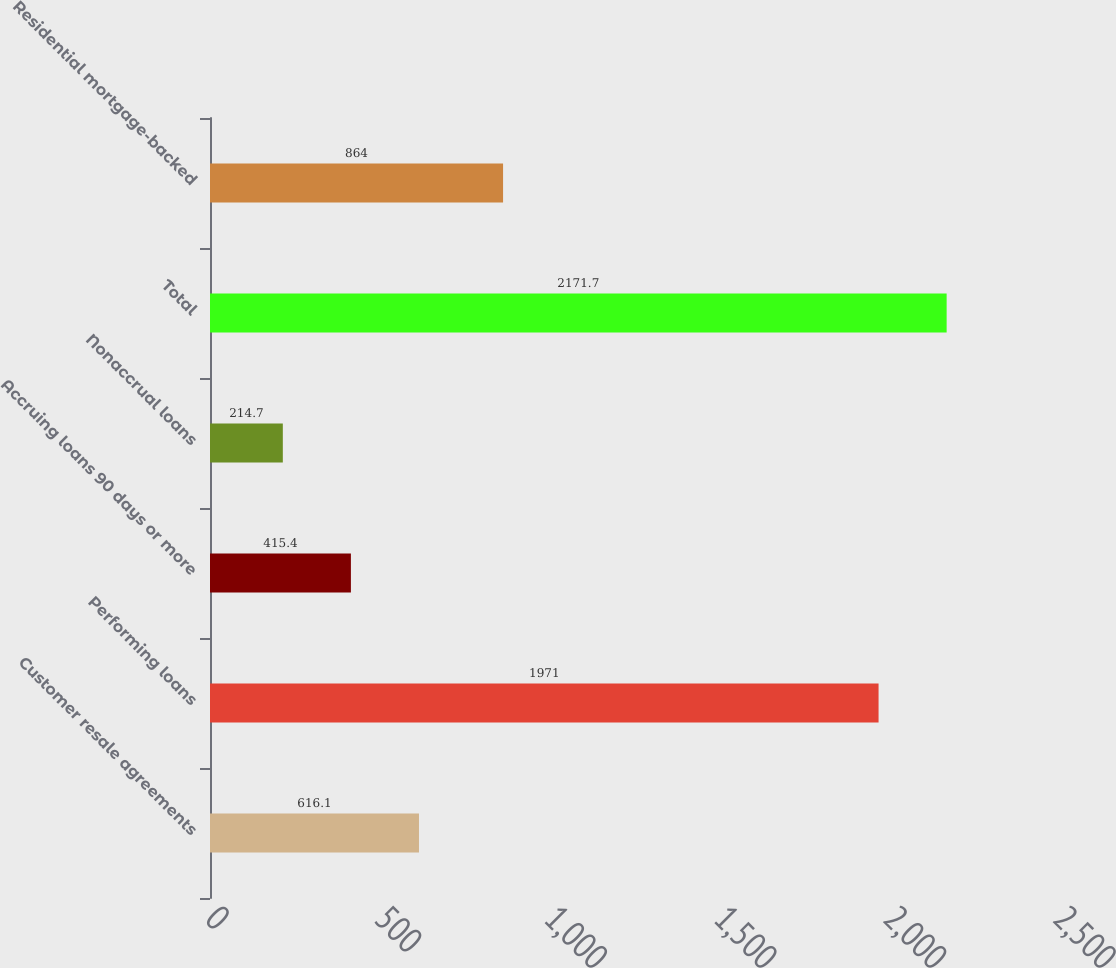Convert chart to OTSL. <chart><loc_0><loc_0><loc_500><loc_500><bar_chart><fcel>Customer resale agreements<fcel>Performing loans<fcel>Accruing loans 90 days or more<fcel>Nonaccrual loans<fcel>Total<fcel>Residential mortgage-backed<nl><fcel>616.1<fcel>1971<fcel>415.4<fcel>214.7<fcel>2171.7<fcel>864<nl></chart> 